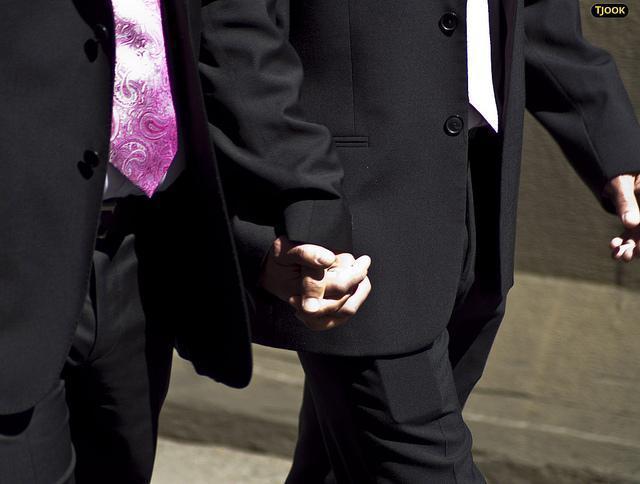How many people are visible?
Give a very brief answer. 2. How many ties can be seen?
Give a very brief answer. 2. 